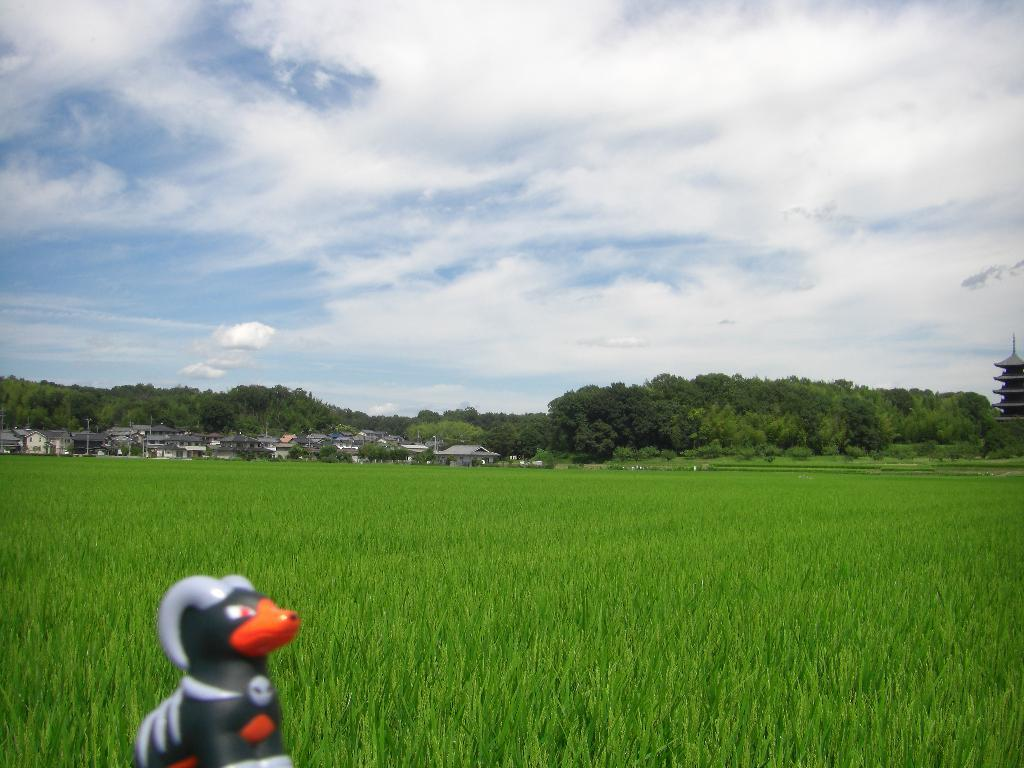What object is located on the left at the bottom of the image? There is a toy on the left at the bottom of the image. What can be seen in the distance in the image? In the background of the image, there is a field, trees, houses, buildings, and clouds in the sky. Where is the kettle placed in the image? There is no kettle present in the image. What type of can is visible in the image? There is no can present in the image. 